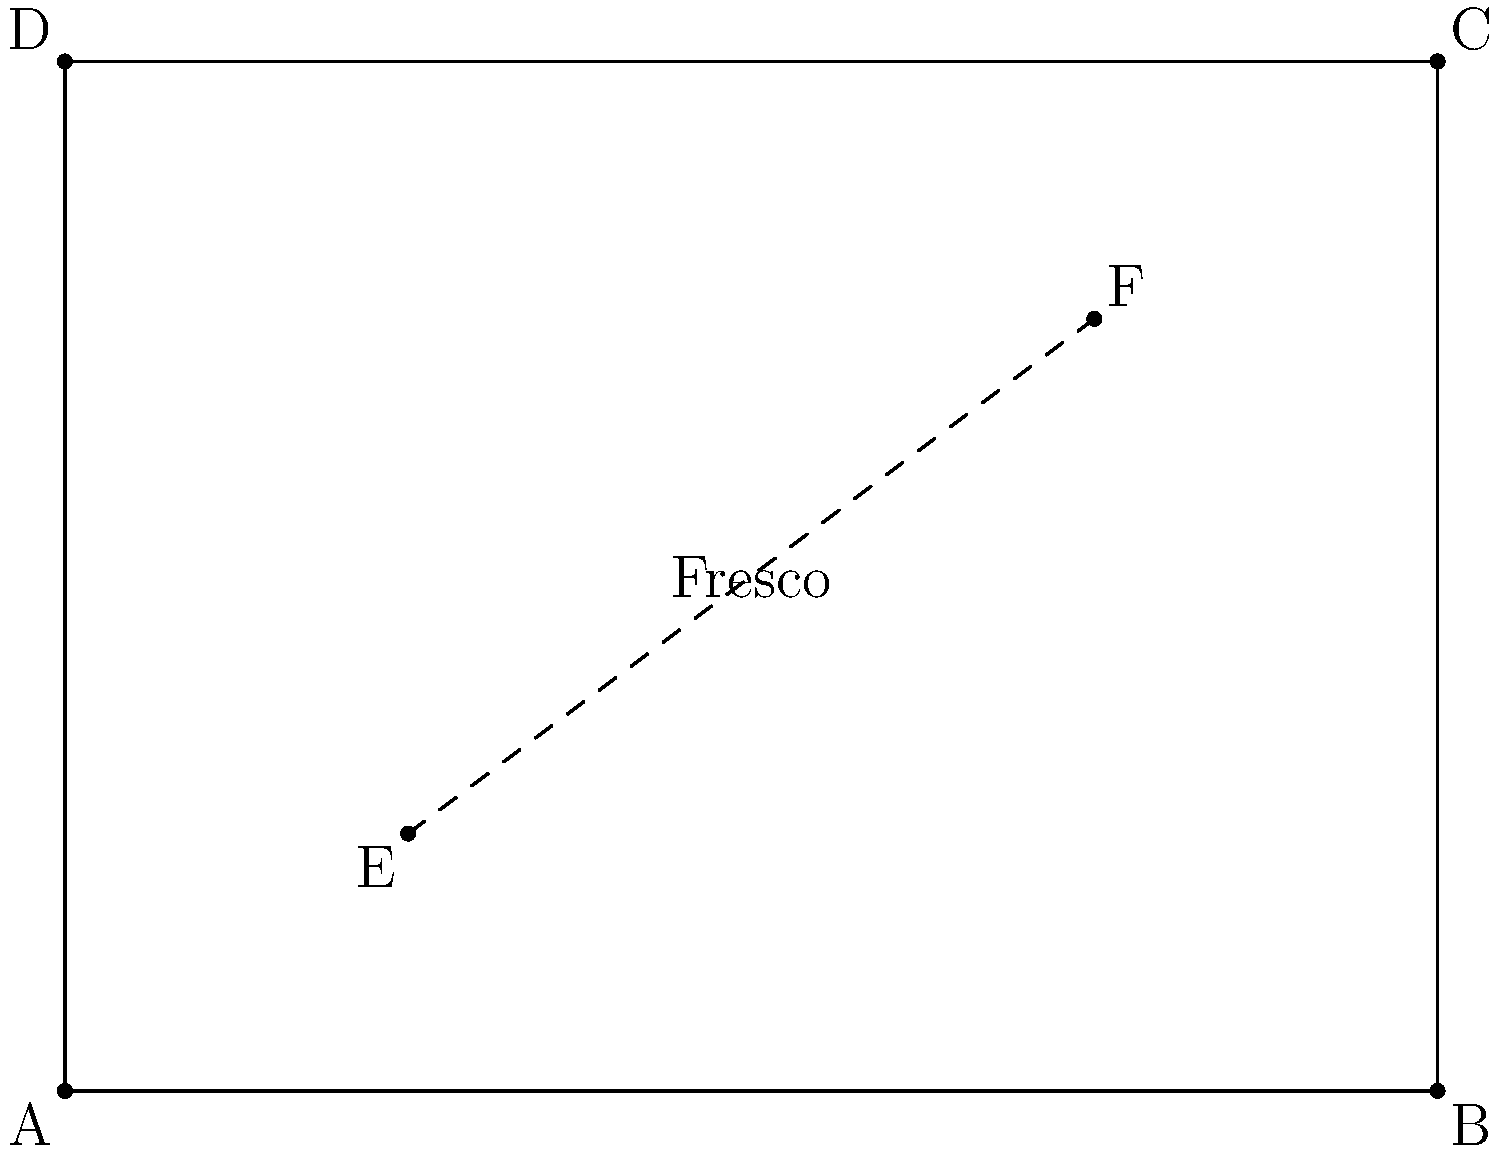In a Renaissance fresco, two parallel horizontal lines in the painting appear to converge at a vanishing point due to perspective. Given that the fresco is represented by the rectangle ABCD, where A(0,0), B(8,0), C(8,6), and D(0,6), and two points E(2,1.5) and F(6,4.5) lie on these converging lines, determine the coordinates of the vanishing point V. Round your answer to two decimal places. To find the vanishing point, we need to extend the line EF to where it intersects with the horizon line (in this case, the line BC). We can do this using the point-slope form of a line equation.

Step 1: Calculate the slope of line EF.
$m = \frac{y_2 - y_1}{x_2 - x_1} = \frac{4.5 - 1.5}{6 - 2} = \frac{3}{4} = 0.75$

Step 2: Use the point-slope form to write the equation of line EF.
$y - y_1 = m(x - x_1)$
$y - 1.5 = 0.75(x - 2)$

Step 3: Simplify the equation to slope-intercept form.
$y = 0.75x + 0$

Step 4: To find the x-coordinate of the vanishing point, set y = 6 (the y-coordinate of line BC) and solve for x.
$6 = 0.75x + 0$
$x = 8$

Step 5: Calculate the y-coordinate by plugging x = 8 into the line equation.
$y = 0.75(8) + 0 = 6$

Therefore, the vanishing point V has coordinates (8, 6), which coincides with point C in this case.
Answer: (8.00, 6.00) 